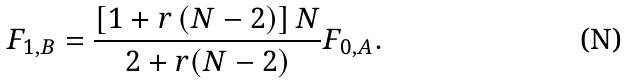<formula> <loc_0><loc_0><loc_500><loc_500>F _ { 1 , B } = \frac { \left [ 1 + r \left ( N - 2 \right ) \right ] N } { 2 + r ( N - 2 ) } F _ { 0 , A } .</formula> 